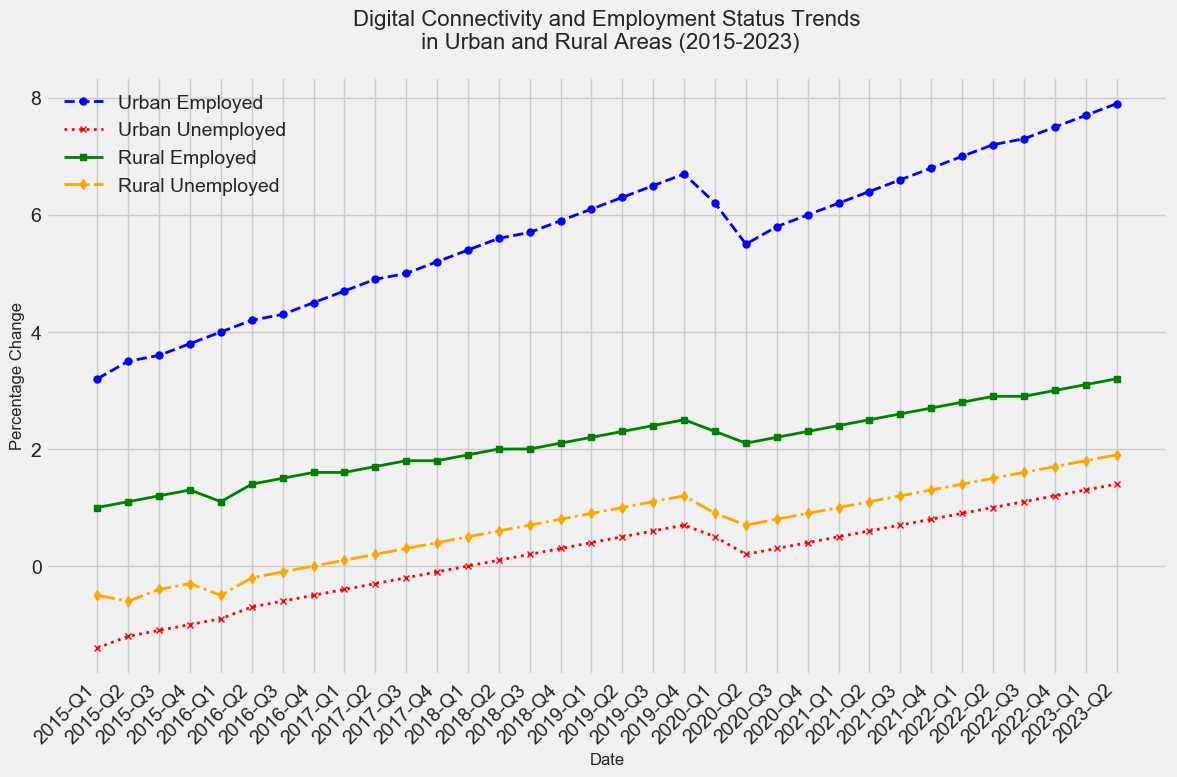What is the trend in urban employment from 2015-Q1 to 2023-Q2? The urban employment percentage increases continuously from about 3.2% in 2015-Q1 to approximately 7.9% in 2023-Q2.
Answer: Increasing How does the trend of rural employment compare to urban employment? Both rural and urban employment show increasing trends, but the rate of increase in urban employment is higher compared to rural employment throughout the period.
Answer: Urban employment increases faster Which quarter first showed a positive value for urban unemployment? Urban unemployment first showed a positive value in 2018-Q1. Before this quarter, all urban unemployment values were negative.
Answer: 2018-Q1 By how much did rural unemployed change from 2015-Q1 to 2023-Q2? Rural unemployment increased from -0.5% in 2015-Q1 to 1.9% in 2023-Q2. The change can be calculated as 1.9 - (-0.5) = 2.4%.
Answer: 2.4% In which year did rural unemployed first exceed 0%? Rural unemployed first exceeded 0% in 2016-Q4.
Answer: 2016-Q4 What colors represent the rural employed and rural unemployed trends, respectively? The rural employed trend is represented by green, and the rural unemployed trend is represented by orange.
Answer: Green and orange Compare the rural employed trend in 2020-Q1 and 2020-Q2. Rural employment dropped from 2.3% in 2020-Q1 to 2.1% in 2020-Q2.
Answer: Decreased Which employment status has the highest value in 2022-Q2? Urban employed had the highest value of approximately 7.2% in 2022-Q2.
Answer: Urban employed What is the difference between urban unemployed and rural unemployed in 2023-Q2? Urban unemployed is 1.4%, and rural unemployed is 1.9% in 2023-Q2. The difference is 1.9% - 1.4% = 0.5%.
Answer: 0.5% Over the entire period, which category shows a decreasing trend? None of the categories show a decreasing trend. All categories either increase or remain relatively stable over the period.
Answer: None 